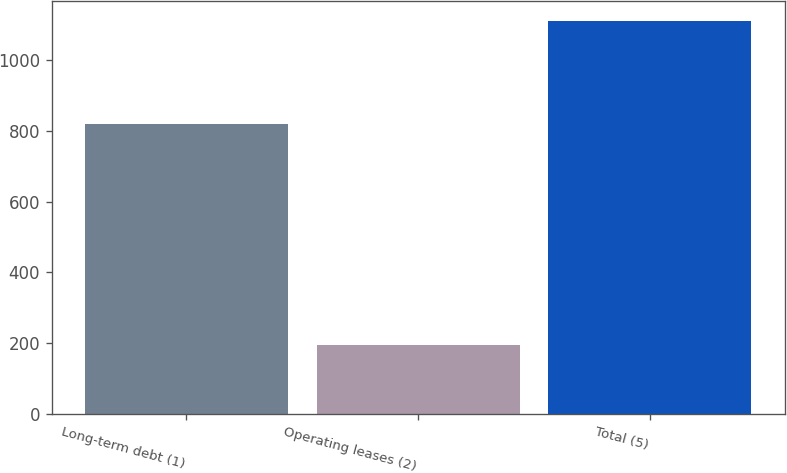<chart> <loc_0><loc_0><loc_500><loc_500><bar_chart><fcel>Long-term debt (1)<fcel>Operating leases (2)<fcel>Total (5)<nl><fcel>819<fcel>194<fcel>1111<nl></chart> 